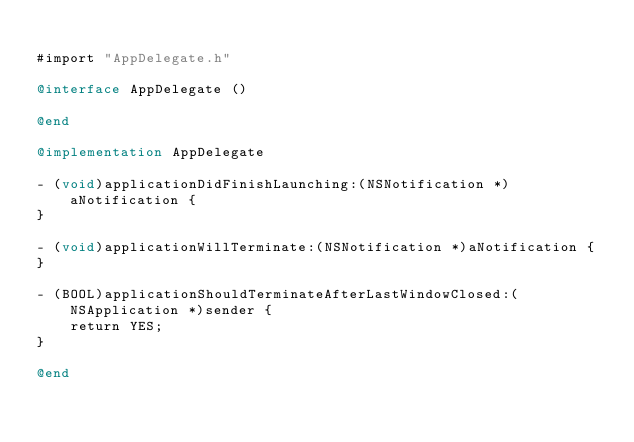<code> <loc_0><loc_0><loc_500><loc_500><_ObjectiveC_>
#import "AppDelegate.h"

@interface AppDelegate ()

@end

@implementation AppDelegate

- (void)applicationDidFinishLaunching:(NSNotification *)aNotification {
}

- (void)applicationWillTerminate:(NSNotification *)aNotification {
}

- (BOOL)applicationShouldTerminateAfterLastWindowClosed:(NSApplication *)sender {
    return YES;
}

@end
</code> 